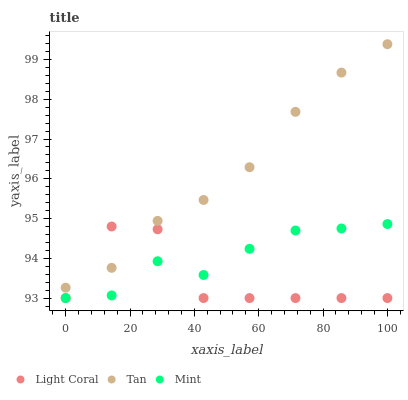Does Light Coral have the minimum area under the curve?
Answer yes or no. Yes. Does Tan have the maximum area under the curve?
Answer yes or no. Yes. Does Mint have the minimum area under the curve?
Answer yes or no. No. Does Mint have the maximum area under the curve?
Answer yes or no. No. Is Tan the smoothest?
Answer yes or no. Yes. Is Light Coral the roughest?
Answer yes or no. Yes. Is Mint the smoothest?
Answer yes or no. No. Is Mint the roughest?
Answer yes or no. No. Does Light Coral have the lowest value?
Answer yes or no. Yes. Does Tan have the lowest value?
Answer yes or no. No. Does Tan have the highest value?
Answer yes or no. Yes. Does Mint have the highest value?
Answer yes or no. No. Is Mint less than Tan?
Answer yes or no. Yes. Is Tan greater than Mint?
Answer yes or no. Yes. Does Tan intersect Light Coral?
Answer yes or no. Yes. Is Tan less than Light Coral?
Answer yes or no. No. Is Tan greater than Light Coral?
Answer yes or no. No. Does Mint intersect Tan?
Answer yes or no. No. 